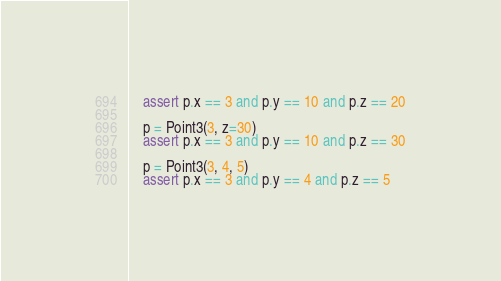Convert code to text. <code><loc_0><loc_0><loc_500><loc_500><_Python_>    assert p.x == 3 and p.y == 10 and p.z == 20

    p = Point3(3, z=30)
    assert p.x == 3 and p.y == 10 and p.z == 30

    p = Point3(3, 4, 5)
    assert p.x == 3 and p.y == 4 and p.z == 5
</code> 